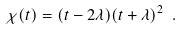<formula> <loc_0><loc_0><loc_500><loc_500>\chi ( t ) = ( t - 2 \lambda ) ( t + \lambda ) ^ { 2 } \ .</formula> 